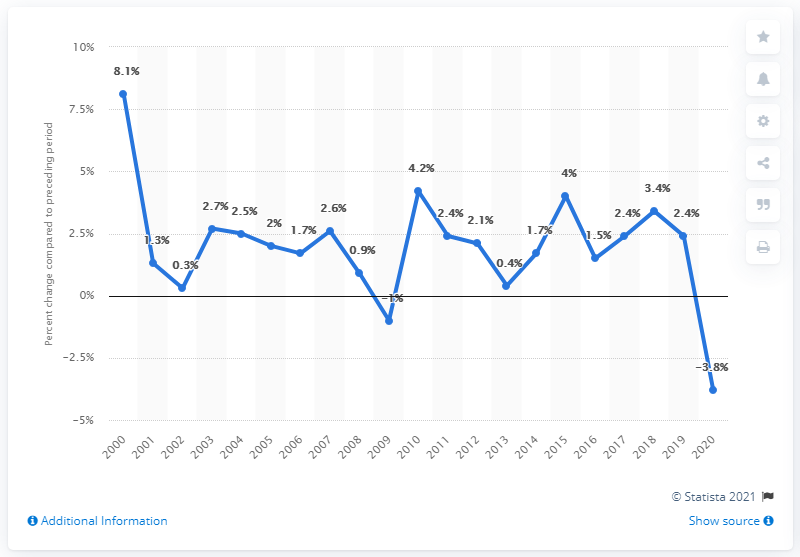Give some essential details in this illustration. In 2000, the Gross Domestic Product (GDP) of the state increased by 8.1%. 